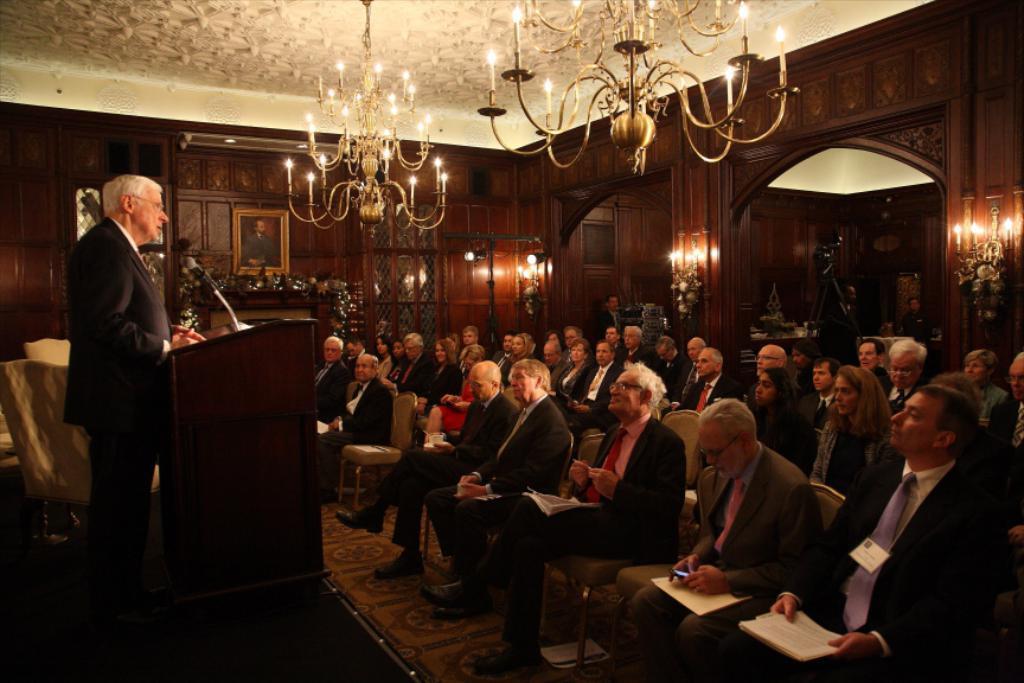In one or two sentences, can you explain what this image depicts? In the image there is an old man in black suit talking on mic on the left side in front of dias and on the right side there are many people sitting on chairs and there are chandeliers on the ceiling, in the back there are photographs on the wall. 